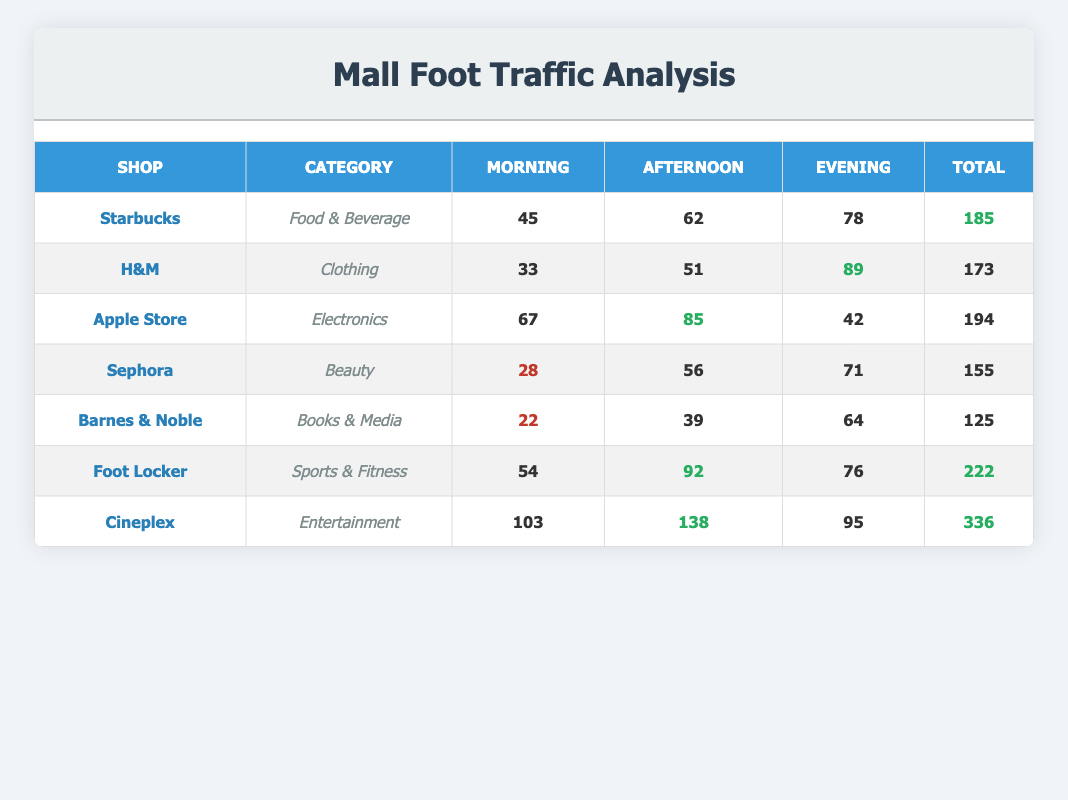What is the total foot traffic for Starbucks? By referring to the Starbucks row, we can see that the foot traffic numbers are 45 (morning) + 62 (afternoon) + 78 (evening). Adding these gives us 185.
Answer: 185 Which shop had the highest foot traffic on Sunday at 4:00 PM? Looking at Sunday, the foot traffic for Cineplex at 4:00 PM is 138 while all other shops are listed for different times or have lower numbers, confirming that Cineplex had the highest at that specific time.
Answer: Cineplex What is the average foot traffic for Apple Store across all times? The Apple Store has foot traffic of 67 (morning), 85 (afternoon), and 42 (evening). The average is calculated as (67 + 85 + 42) / 3 = 194 / 3 = approximately 64.67.
Answer: Approximately 64.67 Is the total foot traffic for Foot Locker greater than 200? The total foot traffic for Foot Locker is obtained from the table as 54 + 92 + 76, which equals 222. Since 222 is greater than 200, the answer is yes.
Answer: Yes On which day did H&M experience the most foot traffic and what was the total? The total foot traffic for H&M is 33 (Monday) + 51 (Tuesday) + 89 (Tuesday) = 173. Since the highest value occurs on Tuesday (89) with the total being 173, that is the day with most foot traffic.
Answer: Tuesday, 173 What is the difference in foot traffic between the morning and evening for Sephora? The morning foot traffic for Sephora is 28 while the evening foot traffic is 71. Calculating the difference gives us 71 - 28 = 43.
Answer: 43 Did any shop have more foot traffic in the afternoon than the total for Barnes & Noble? The total for Barnes & Noble is 125. In the afternoon, looking at the table, the following shops exceeded that: Starbucks (62), H&M (51), Apple Store (85), Sephora (56), Foot Locker (92), and Cineplex (138). Since Cineplex had 138, the answer is yes.
Answer: Yes What is the total foot traffic across all shops on Saturday? The total foot traffic on Saturday can be calculated by summing the foot traffic for each shop: Foot Locker (54 + 92 + 76) = 222. So for Saturday, the total is 222.
Answer: 222 Which shop has the lowest total foot traffic overall? By examining the total foot traffic for each shop, Barnes & Noble has the lowest total at 125.
Answer: Barnes & Noble 